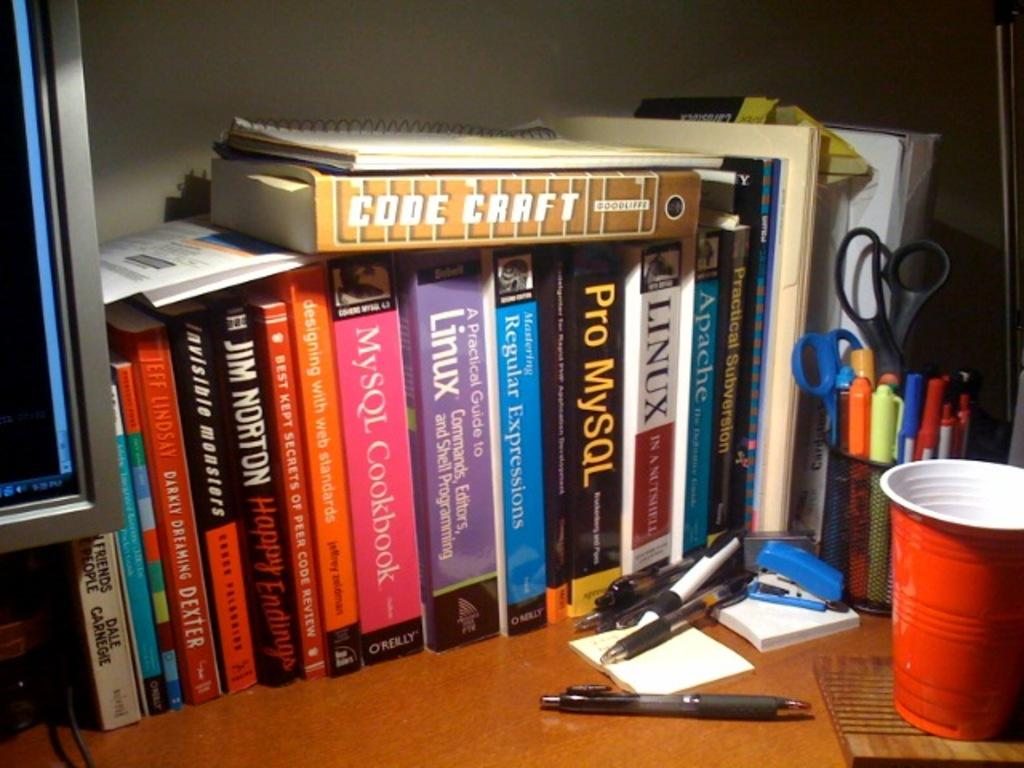Provide a one-sentence caption for the provided image. Shelf full of books including one that says Pro MySQL. 